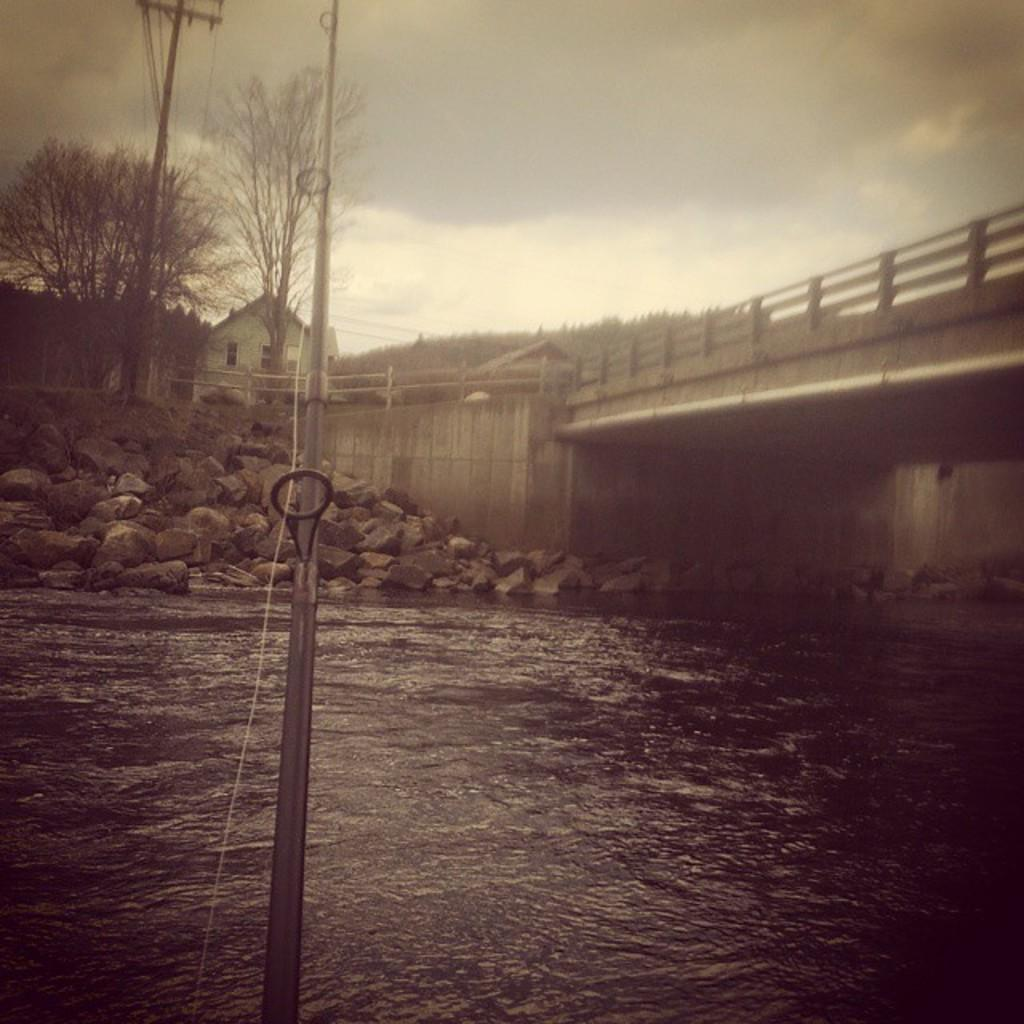What type of structure can be seen in the image? There is a house in the image. What other features are present in the image? There is a bridge, rocks, trees, poles, wires, and a hill visible in the image. What can be seen in the sky in the image? The sky is visible in the image. How many bikes are parked near the house in the image? There are no bikes visible in the image. Can you describe the kiss between the trees in the image? There is no kiss present in the image; it features a house, a bridge, rocks, trees, poles, wires, and a hill. 